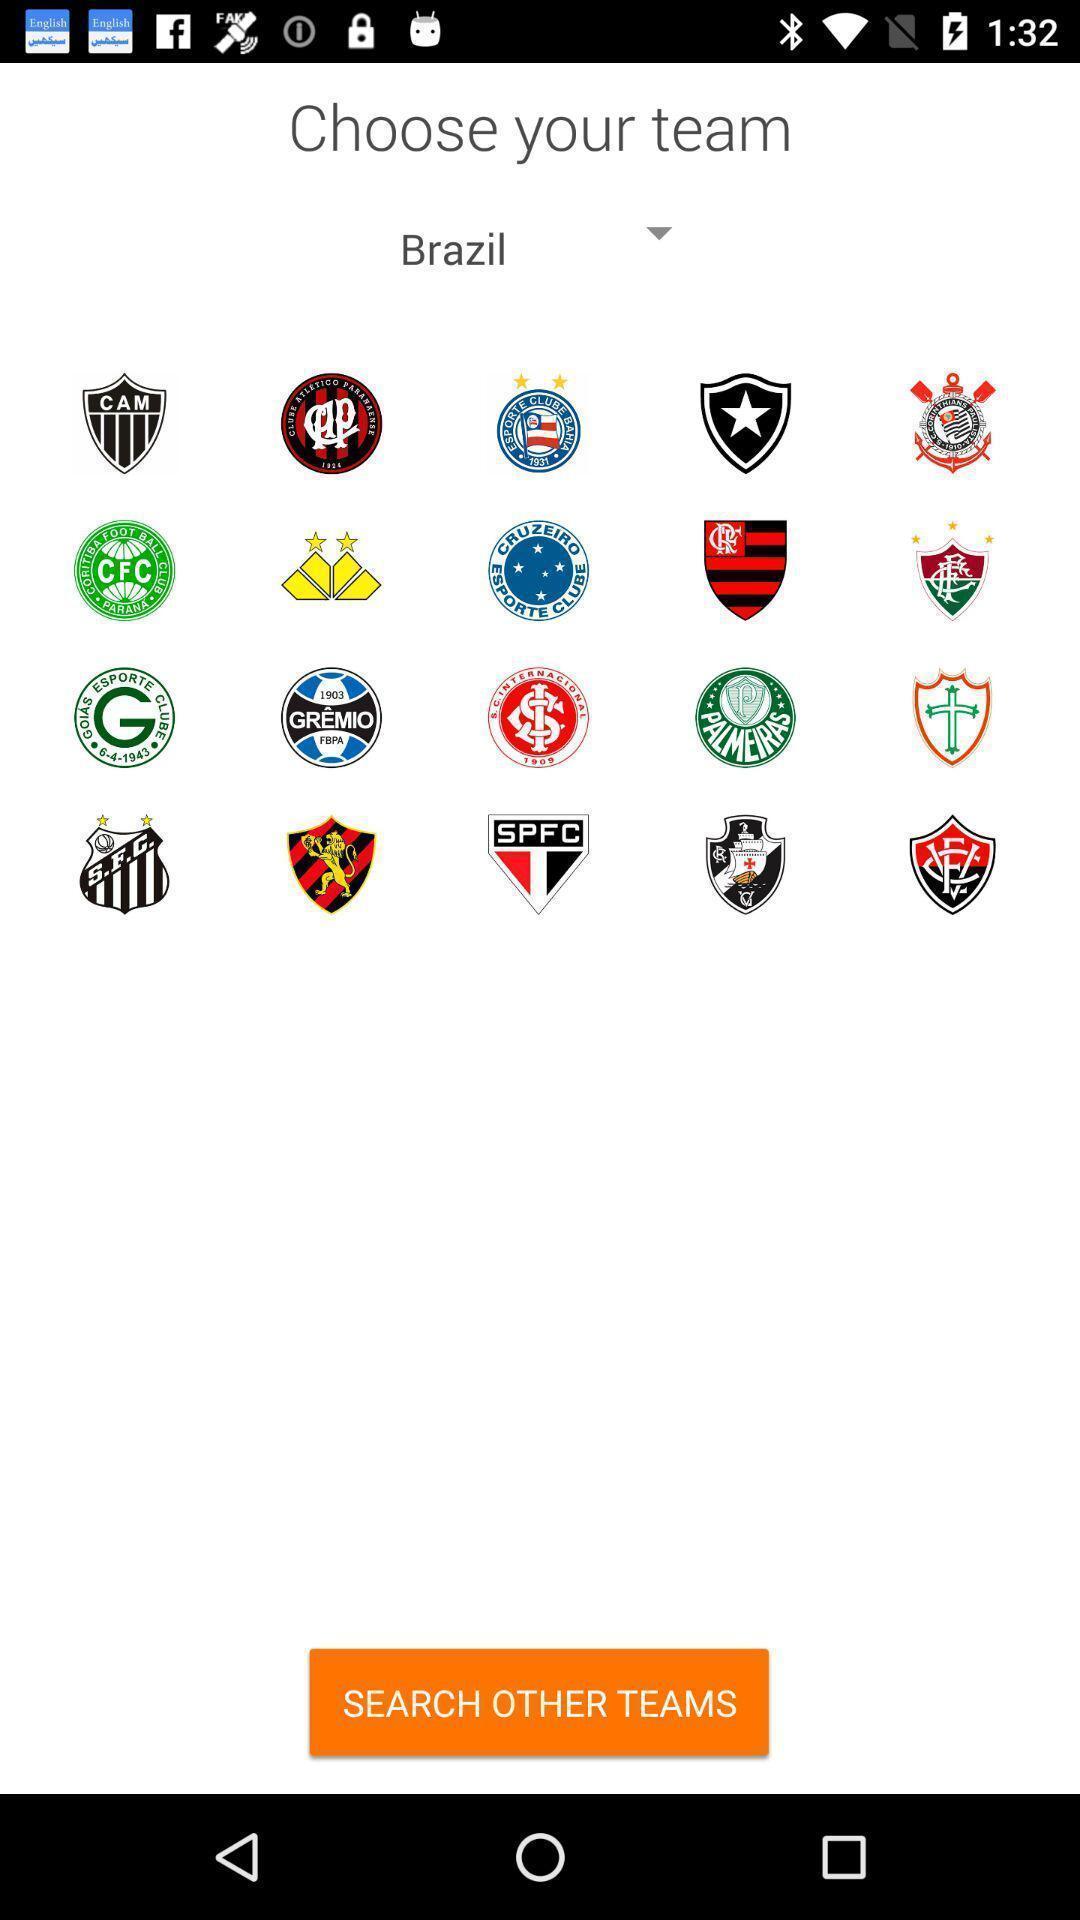What can you discern from this picture? Page requesting to choose a team on an app. 